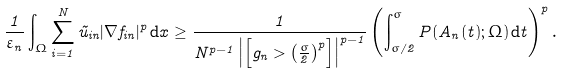<formula> <loc_0><loc_0><loc_500><loc_500>\frac { 1 } { \varepsilon _ { n } } \int _ { \Omega } \sum _ { i = 1 } ^ { N } \tilde { u } _ { i n } | \nabla f _ { i n } | ^ { p } \, \mathrm d x \geq \frac { 1 } { N ^ { p - 1 } \left | \left [ g _ { n } > \left ( \frac { \sigma } { 2 } \right ) ^ { p } \right ] \right | ^ { p - 1 } } \left ( \int _ { \sigma / 2 } ^ { \sigma } P ( A _ { n } ( t ) ; \Omega ) \, \mathrm d t \right ) ^ { p } .</formula> 